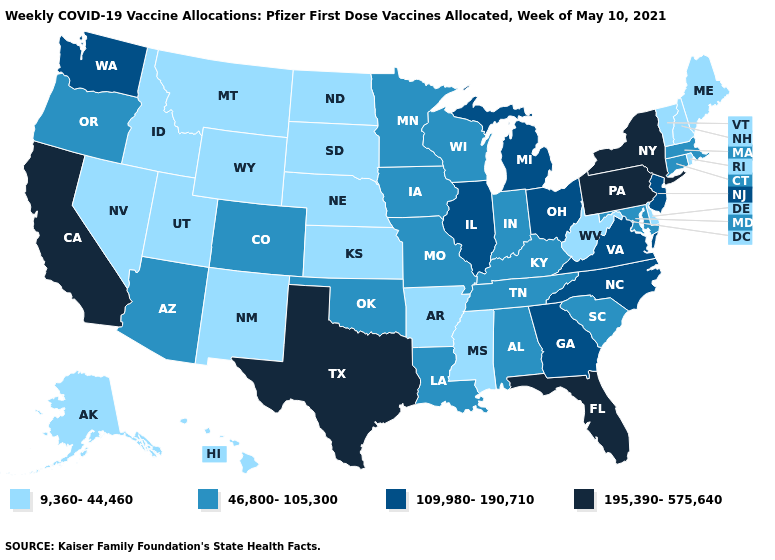Among the states that border Nebraska , does Colorado have the highest value?
Answer briefly. Yes. What is the lowest value in states that border Kentucky?
Concise answer only. 9,360-44,460. Does the map have missing data?
Answer briefly. No. Does Kentucky have a lower value than Texas?
Short answer required. Yes. What is the value of Florida?
Be succinct. 195,390-575,640. Does Rhode Island have the highest value in the Northeast?
Write a very short answer. No. Does Arizona have a lower value than Nevada?
Write a very short answer. No. What is the value of Florida?
Quick response, please. 195,390-575,640. Name the states that have a value in the range 46,800-105,300?
Short answer required. Alabama, Arizona, Colorado, Connecticut, Indiana, Iowa, Kentucky, Louisiana, Maryland, Massachusetts, Minnesota, Missouri, Oklahoma, Oregon, South Carolina, Tennessee, Wisconsin. Name the states that have a value in the range 195,390-575,640?
Keep it brief. California, Florida, New York, Pennsylvania, Texas. Does Pennsylvania have the highest value in the Northeast?
Give a very brief answer. Yes. Name the states that have a value in the range 195,390-575,640?
Short answer required. California, Florida, New York, Pennsylvania, Texas. How many symbols are there in the legend?
Write a very short answer. 4. Among the states that border Arkansas , does Mississippi have the lowest value?
Keep it brief. Yes. 